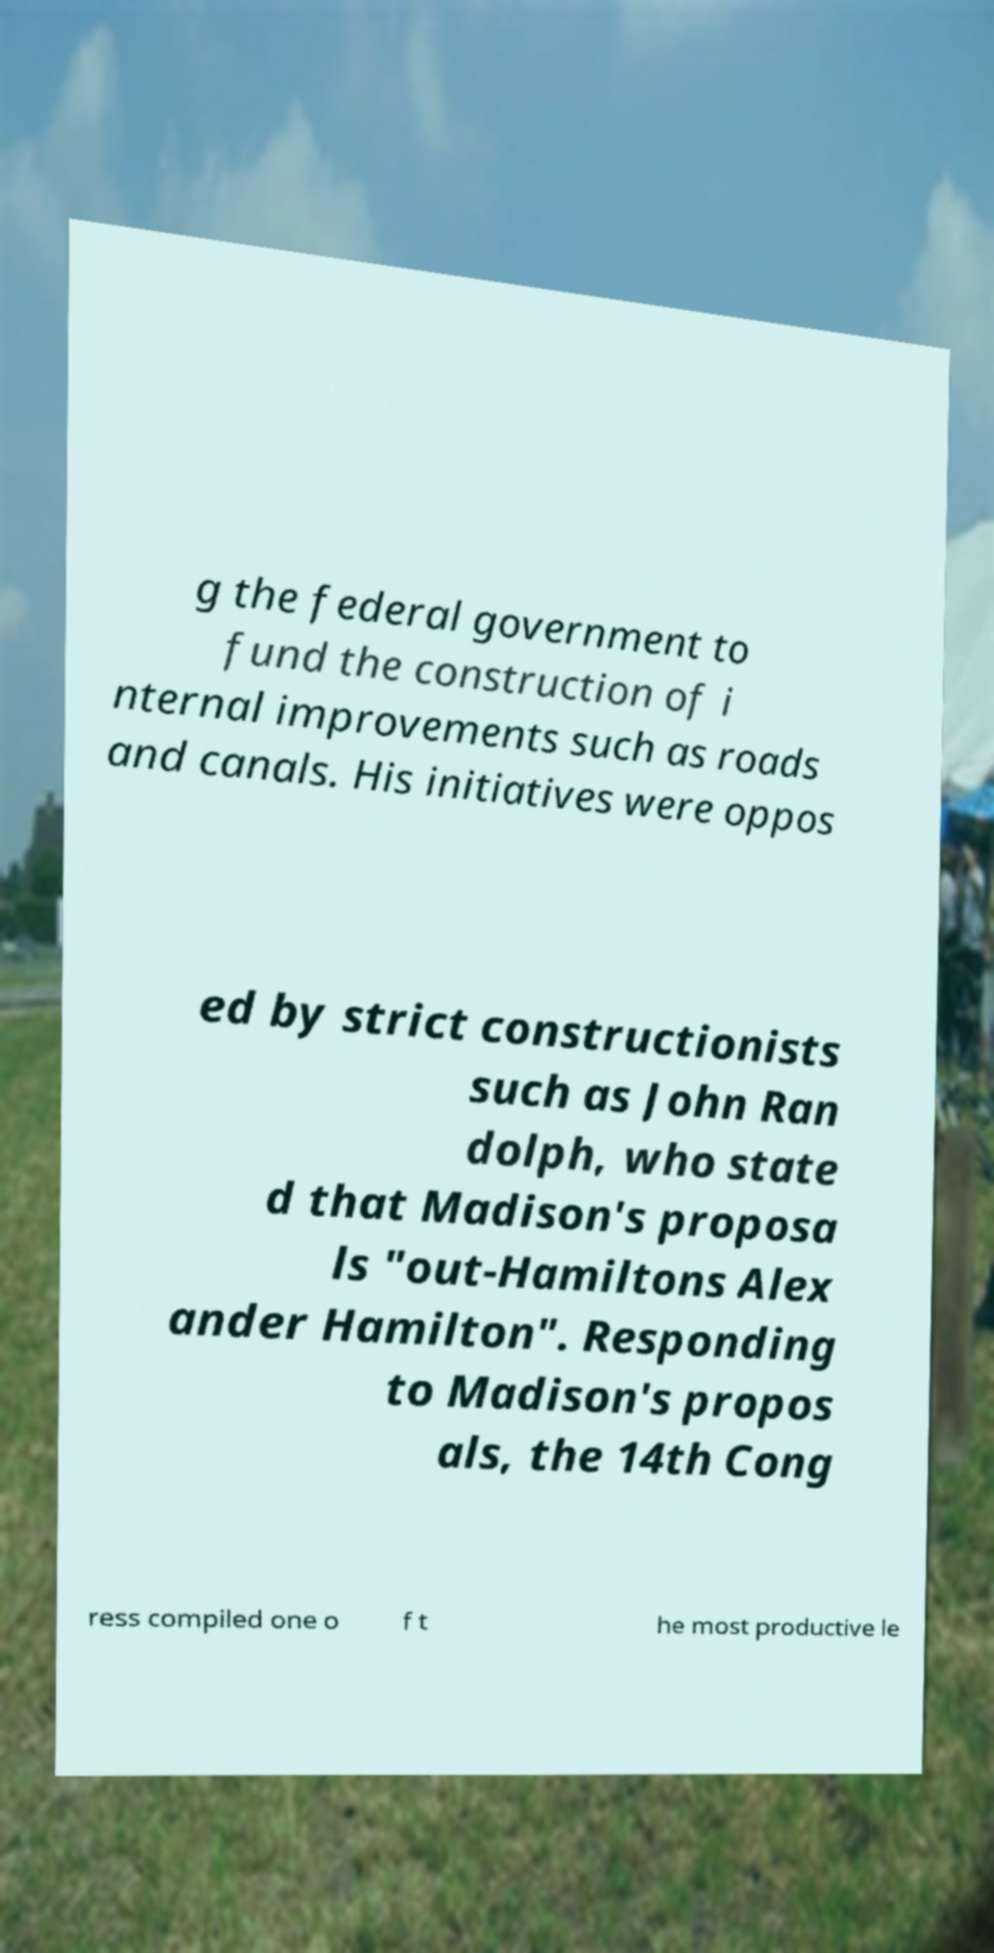I need the written content from this picture converted into text. Can you do that? g the federal government to fund the construction of i nternal improvements such as roads and canals. His initiatives were oppos ed by strict constructionists such as John Ran dolph, who state d that Madison's proposa ls "out-Hamiltons Alex ander Hamilton". Responding to Madison's propos als, the 14th Cong ress compiled one o f t he most productive le 